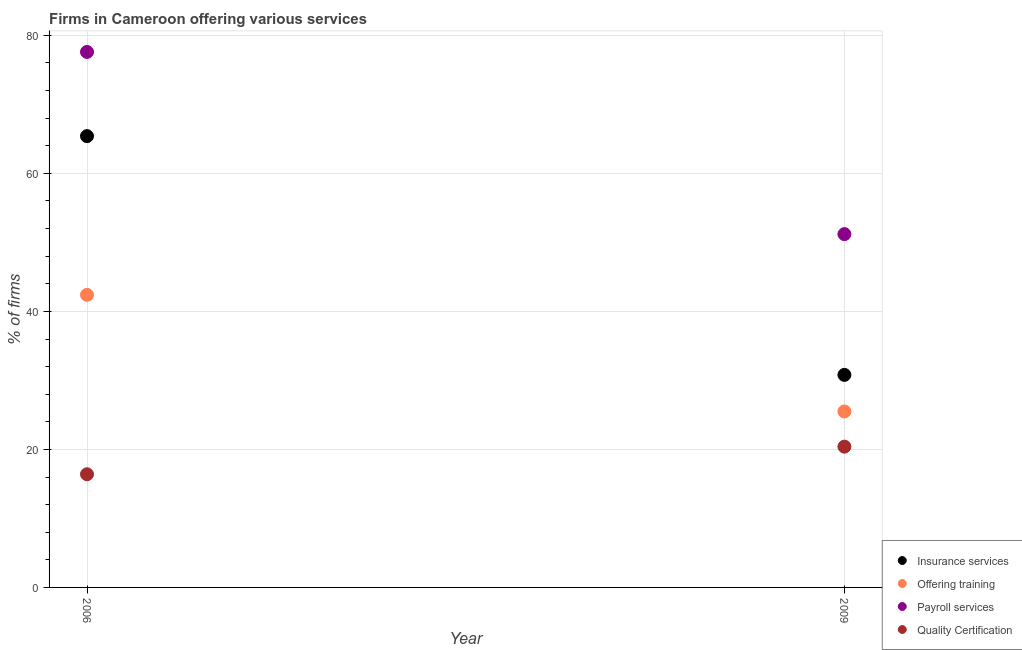How many different coloured dotlines are there?
Provide a short and direct response. 4. Is the number of dotlines equal to the number of legend labels?
Ensure brevity in your answer.  Yes. What is the percentage of firms offering insurance services in 2006?
Keep it short and to the point. 65.4. Across all years, what is the maximum percentage of firms offering training?
Your answer should be compact. 42.4. Across all years, what is the minimum percentage of firms offering insurance services?
Ensure brevity in your answer.  30.8. In which year was the percentage of firms offering training maximum?
Your response must be concise. 2006. In which year was the percentage of firms offering insurance services minimum?
Provide a short and direct response. 2009. What is the total percentage of firms offering insurance services in the graph?
Provide a short and direct response. 96.2. What is the difference between the percentage of firms offering payroll services in 2006 and that in 2009?
Offer a terse response. 26.4. What is the difference between the percentage of firms offering quality certification in 2006 and the percentage of firms offering training in 2009?
Give a very brief answer. -9.1. What is the average percentage of firms offering quality certification per year?
Offer a terse response. 18.4. In the year 2009, what is the difference between the percentage of firms offering insurance services and percentage of firms offering training?
Offer a very short reply. 5.3. What is the ratio of the percentage of firms offering quality certification in 2006 to that in 2009?
Ensure brevity in your answer.  0.8. Is the percentage of firms offering payroll services in 2006 less than that in 2009?
Provide a succinct answer. No. Is it the case that in every year, the sum of the percentage of firms offering insurance services and percentage of firms offering training is greater than the percentage of firms offering payroll services?
Give a very brief answer. Yes. Is the percentage of firms offering training strictly less than the percentage of firms offering insurance services over the years?
Ensure brevity in your answer.  Yes. How many dotlines are there?
Give a very brief answer. 4. Does the graph contain any zero values?
Keep it short and to the point. No. Where does the legend appear in the graph?
Keep it short and to the point. Bottom right. How many legend labels are there?
Your response must be concise. 4. How are the legend labels stacked?
Keep it short and to the point. Vertical. What is the title of the graph?
Provide a succinct answer. Firms in Cameroon offering various services . What is the label or title of the Y-axis?
Offer a very short reply. % of firms. What is the % of firms in Insurance services in 2006?
Your response must be concise. 65.4. What is the % of firms in Offering training in 2006?
Your answer should be very brief. 42.4. What is the % of firms of Payroll services in 2006?
Make the answer very short. 77.6. What is the % of firms of Insurance services in 2009?
Keep it short and to the point. 30.8. What is the % of firms of Offering training in 2009?
Your answer should be compact. 25.5. What is the % of firms in Payroll services in 2009?
Offer a terse response. 51.2. What is the % of firms of Quality Certification in 2009?
Offer a terse response. 20.4. Across all years, what is the maximum % of firms of Insurance services?
Your answer should be very brief. 65.4. Across all years, what is the maximum % of firms of Offering training?
Ensure brevity in your answer.  42.4. Across all years, what is the maximum % of firms in Payroll services?
Provide a succinct answer. 77.6. Across all years, what is the maximum % of firms of Quality Certification?
Your answer should be compact. 20.4. Across all years, what is the minimum % of firms of Insurance services?
Make the answer very short. 30.8. Across all years, what is the minimum % of firms of Payroll services?
Your answer should be very brief. 51.2. Across all years, what is the minimum % of firms in Quality Certification?
Your answer should be very brief. 16.4. What is the total % of firms in Insurance services in the graph?
Your response must be concise. 96.2. What is the total % of firms of Offering training in the graph?
Your answer should be very brief. 67.9. What is the total % of firms in Payroll services in the graph?
Offer a terse response. 128.8. What is the total % of firms of Quality Certification in the graph?
Your answer should be compact. 36.8. What is the difference between the % of firms of Insurance services in 2006 and that in 2009?
Keep it short and to the point. 34.6. What is the difference between the % of firms in Payroll services in 2006 and that in 2009?
Offer a terse response. 26.4. What is the difference between the % of firms in Quality Certification in 2006 and that in 2009?
Ensure brevity in your answer.  -4. What is the difference between the % of firms in Insurance services in 2006 and the % of firms in Offering training in 2009?
Your response must be concise. 39.9. What is the difference between the % of firms of Insurance services in 2006 and the % of firms of Quality Certification in 2009?
Your response must be concise. 45. What is the difference between the % of firms of Offering training in 2006 and the % of firms of Payroll services in 2009?
Ensure brevity in your answer.  -8.8. What is the difference between the % of firms of Payroll services in 2006 and the % of firms of Quality Certification in 2009?
Provide a short and direct response. 57.2. What is the average % of firms in Insurance services per year?
Keep it short and to the point. 48.1. What is the average % of firms in Offering training per year?
Your answer should be very brief. 33.95. What is the average % of firms in Payroll services per year?
Your response must be concise. 64.4. In the year 2006, what is the difference between the % of firms of Insurance services and % of firms of Offering training?
Your answer should be very brief. 23. In the year 2006, what is the difference between the % of firms of Insurance services and % of firms of Payroll services?
Ensure brevity in your answer.  -12.2. In the year 2006, what is the difference between the % of firms in Offering training and % of firms in Payroll services?
Make the answer very short. -35.2. In the year 2006, what is the difference between the % of firms of Offering training and % of firms of Quality Certification?
Provide a succinct answer. 26. In the year 2006, what is the difference between the % of firms in Payroll services and % of firms in Quality Certification?
Offer a terse response. 61.2. In the year 2009, what is the difference between the % of firms in Insurance services and % of firms in Payroll services?
Provide a succinct answer. -20.4. In the year 2009, what is the difference between the % of firms in Insurance services and % of firms in Quality Certification?
Offer a terse response. 10.4. In the year 2009, what is the difference between the % of firms in Offering training and % of firms in Payroll services?
Your response must be concise. -25.7. In the year 2009, what is the difference between the % of firms in Payroll services and % of firms in Quality Certification?
Your answer should be compact. 30.8. What is the ratio of the % of firms of Insurance services in 2006 to that in 2009?
Make the answer very short. 2.12. What is the ratio of the % of firms in Offering training in 2006 to that in 2009?
Offer a terse response. 1.66. What is the ratio of the % of firms of Payroll services in 2006 to that in 2009?
Make the answer very short. 1.52. What is the ratio of the % of firms of Quality Certification in 2006 to that in 2009?
Offer a terse response. 0.8. What is the difference between the highest and the second highest % of firms of Insurance services?
Offer a terse response. 34.6. What is the difference between the highest and the second highest % of firms of Offering training?
Provide a short and direct response. 16.9. What is the difference between the highest and the second highest % of firms in Payroll services?
Ensure brevity in your answer.  26.4. What is the difference between the highest and the lowest % of firms of Insurance services?
Your answer should be very brief. 34.6. What is the difference between the highest and the lowest % of firms of Offering training?
Offer a terse response. 16.9. What is the difference between the highest and the lowest % of firms in Payroll services?
Your response must be concise. 26.4. What is the difference between the highest and the lowest % of firms in Quality Certification?
Keep it short and to the point. 4. 